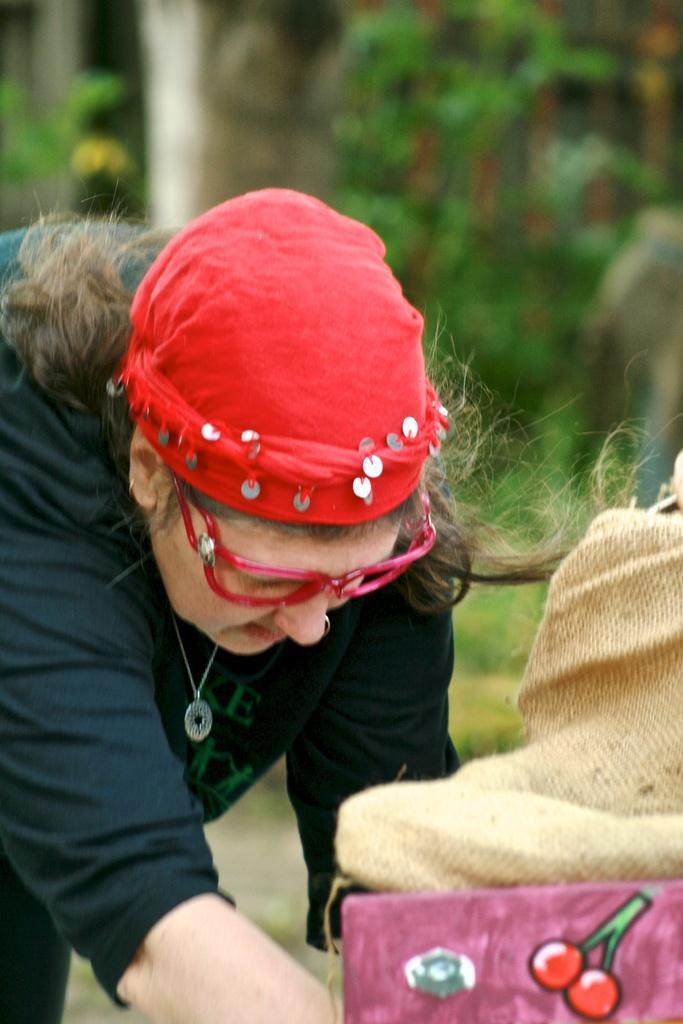Please provide a concise description of this image. In this image in the center there is a woman. In the front there is an object which is pink in colour and on the object there is a jute bag and the background is blurry. 